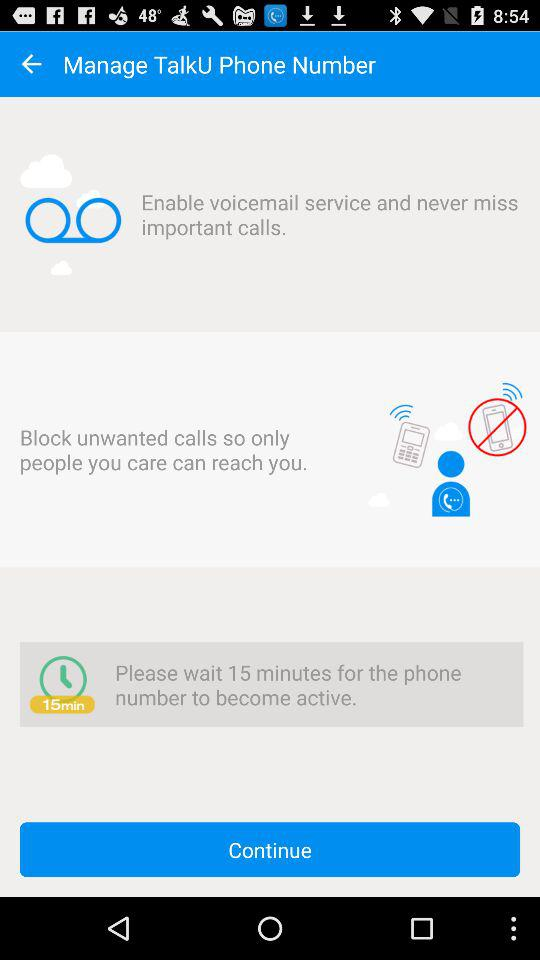How many minutes will it take for the phone number to become active?
Answer the question using a single word or phrase. 15 